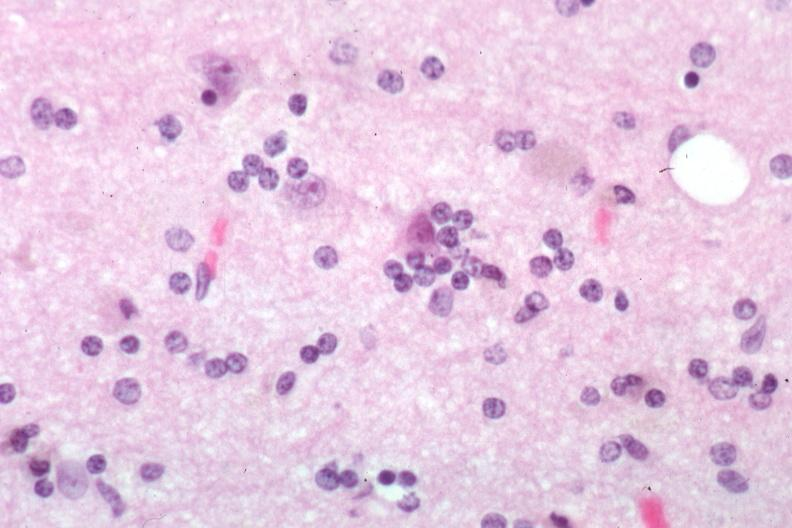s neuronophagia present?
Answer the question using a single word or phrase. Yes 